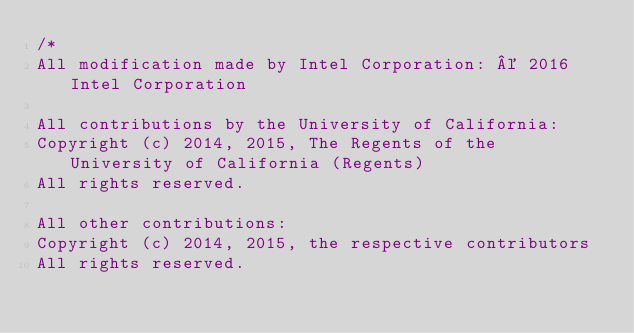<code> <loc_0><loc_0><loc_500><loc_500><_Cuda_>/*
All modification made by Intel Corporation: © 2016 Intel Corporation

All contributions by the University of California:
Copyright (c) 2014, 2015, The Regents of the University of California (Regents)
All rights reserved.

All other contributions:
Copyright (c) 2014, 2015, the respective contributors
All rights reserved.</code> 